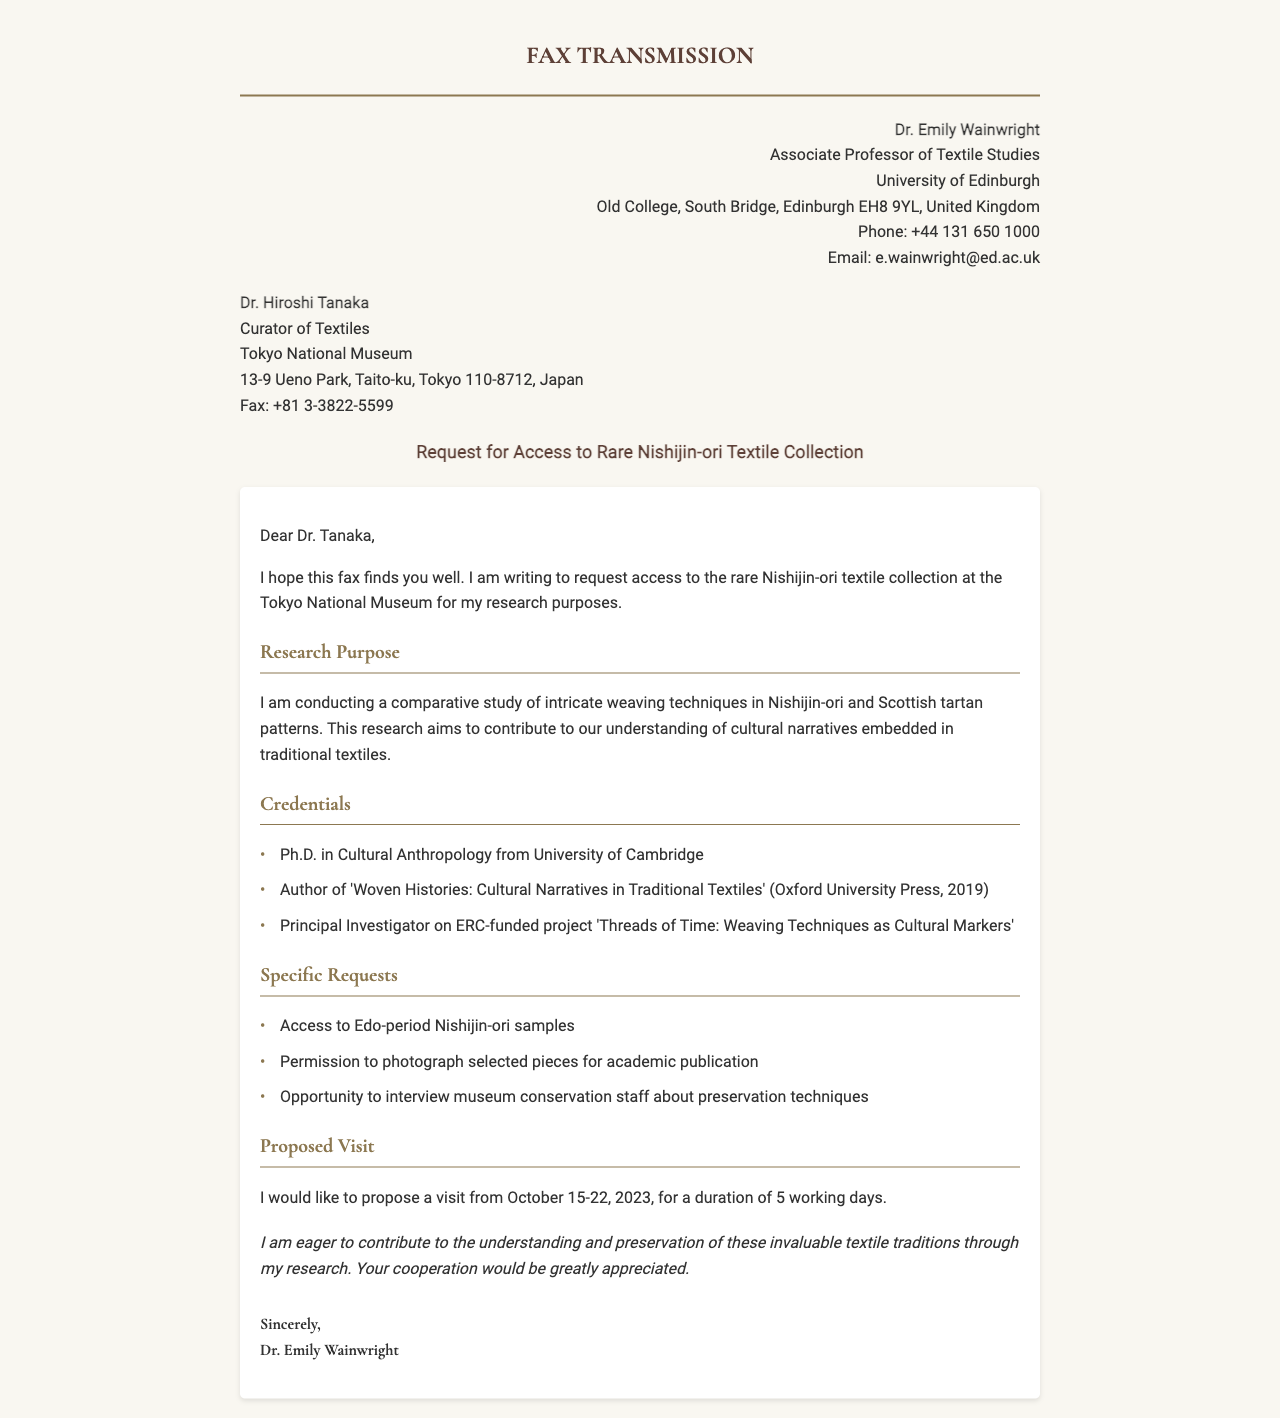What is the sender's title? The sender's title is provided in the document as "Associate Professor of Textile Studies."
Answer: Associate Professor of Textile Studies What is the recipient's name? The recipient's name is explicitly stated in the introduction as "Dr. Hiroshi Tanaka."
Answer: Dr. Hiroshi Tanaka What is the subject of the fax? The subject of the fax is mentioned clearly in the document as "Request for Access to Rare Nishijin-ori Textile Collection."
Answer: Request for Access to Rare Nishijin-ori Textile Collection How many specific requests are listed? The document lists three specific requests under the "Specific Requests" section.
Answer: 3 What is the proposed visit duration? The duration of the proposed visit is specified in the document as "5 working days."
Answer: 5 working days What type of research is Dr. Wainwright conducting? The research type is described in the document as a "comparative study of intricate weaving techniques."
Answer: Comparative study of intricate weaving techniques What is the deadline for the proposed visit? The proposed visit dates are stated in the document as "from October 15-22, 2023."
Answer: October 15-22, 2023 What is the email address of the sender? The sender's email address is clearly listed in the document as "e.wainwright@ed.ac.uk."
Answer: e.wainwright@ed.ac.uk What is the main goal of Dr. Wainwright's research? The main goal is mentioned as contributing to "understanding of cultural narratives embedded in traditional textiles."
Answer: Understanding of cultural narratives embedded in traditional textiles 